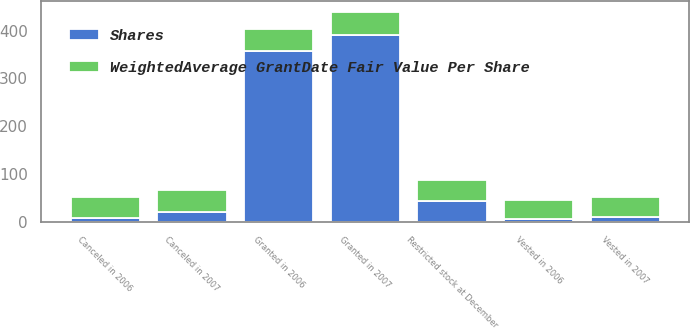Convert chart to OTSL. <chart><loc_0><loc_0><loc_500><loc_500><stacked_bar_chart><ecel><fcel>Restricted stock at December<fcel>Granted in 2006<fcel>Canceled in 2006<fcel>Vested in 2006<fcel>Granted in 2007<fcel>Canceled in 2007<fcel>Vested in 2007<nl><fcel>Shares<fcel>42.92<fcel>357<fcel>8<fcel>6<fcel>391<fcel>21<fcel>9<nl><fcel>WeightedAverage GrantDate Fair Value Per Share<fcel>43.84<fcel>46.96<fcel>42.92<fcel>38.75<fcel>48.43<fcel>45.88<fcel>42.06<nl></chart> 